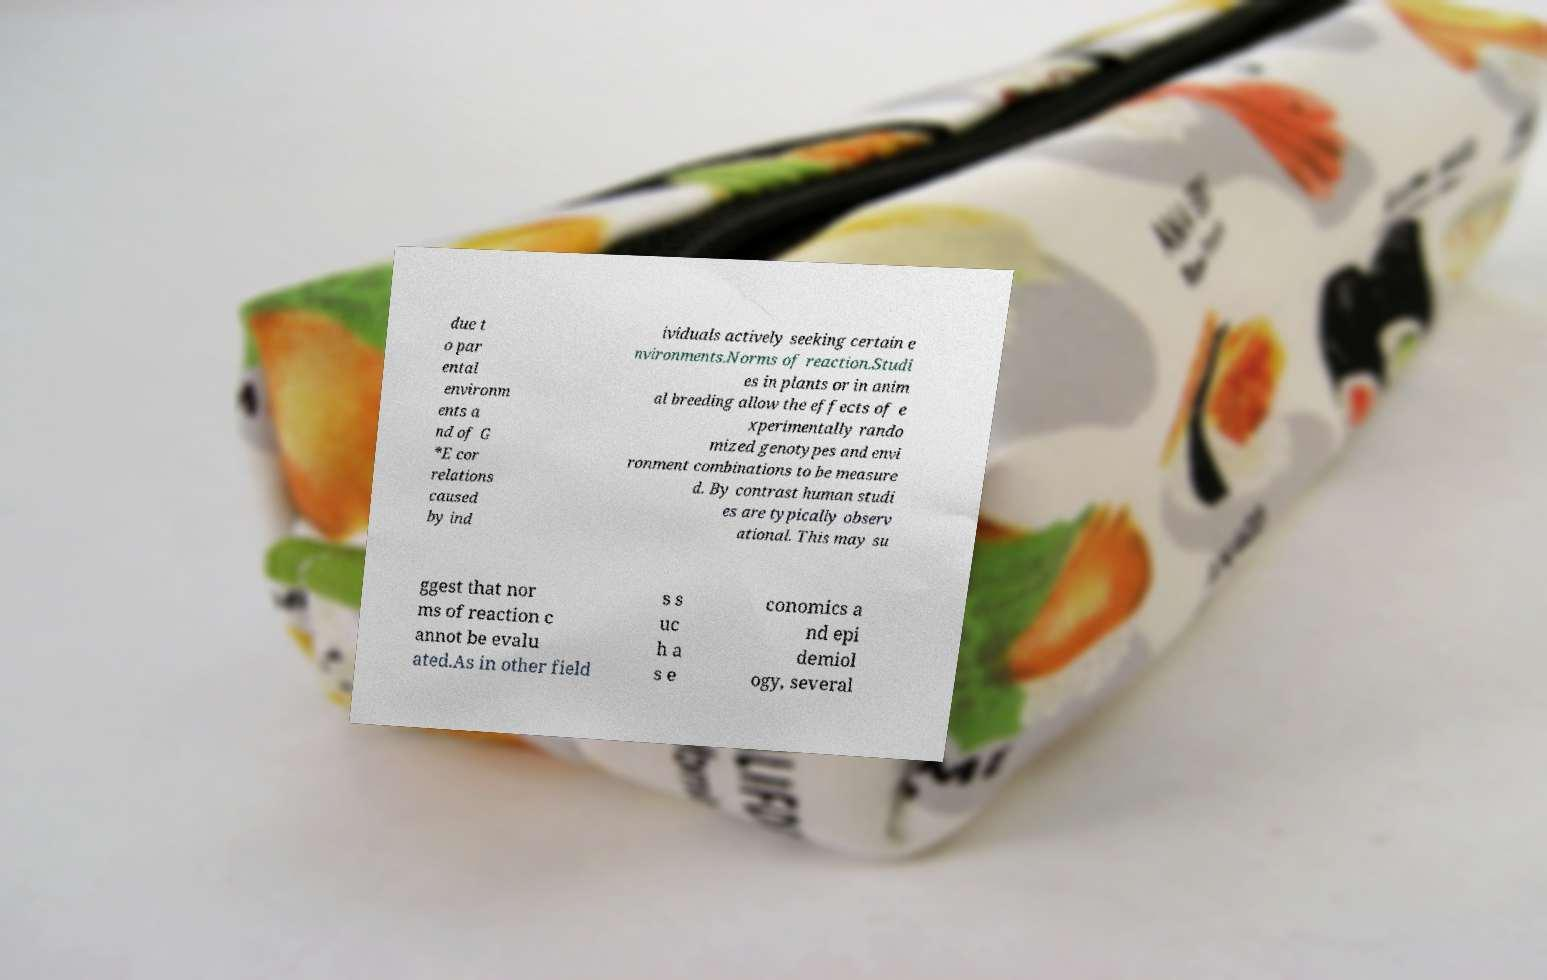For documentation purposes, I need the text within this image transcribed. Could you provide that? due t o par ental environm ents a nd of G *E cor relations caused by ind ividuals actively seeking certain e nvironments.Norms of reaction.Studi es in plants or in anim al breeding allow the effects of e xperimentally rando mized genotypes and envi ronment combinations to be measure d. By contrast human studi es are typically observ ational. This may su ggest that nor ms of reaction c annot be evalu ated.As in other field s s uc h a s e conomics a nd epi demiol ogy, several 